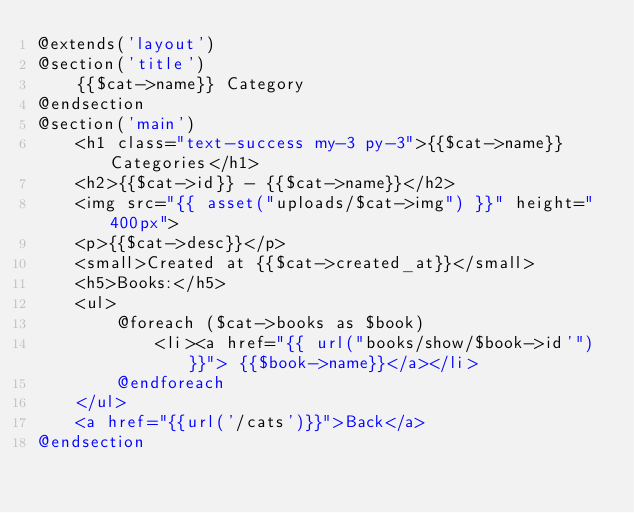<code> <loc_0><loc_0><loc_500><loc_500><_PHP_>@extends('layout')
@section('title')
    {{$cat->name}} Category
@endsection
@section('main')
    <h1 class="text-success my-3 py-3">{{$cat->name}} Categories</h1>
    <h2>{{$cat->id}} - {{$cat->name}}</h2>
    <img src="{{ asset("uploads/$cat->img") }}" height="400px">
    <p>{{$cat->desc}}</p>
    <small>Created at {{$cat->created_at}}</small>
    <h5>Books:</h5>
    <ul>
        @foreach ($cat->books as $book)
            <li><a href="{{ url("books/show/$book->id'")}}"> {{$book->name}}</a></li>
        @endforeach
    </ul>
    <a href="{{url('/cats')}}">Back</a>
@endsection</code> 